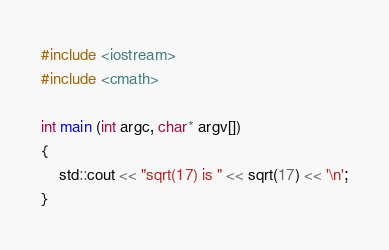Convert code to text. <code><loc_0><loc_0><loc_500><loc_500><_C++_>#include <iostream>
#include <cmath>

int main (int argc, char* argv[]) 
{
    std::cout << "sqrt(17) is " << sqrt(17) << '\n';
}

</code> 